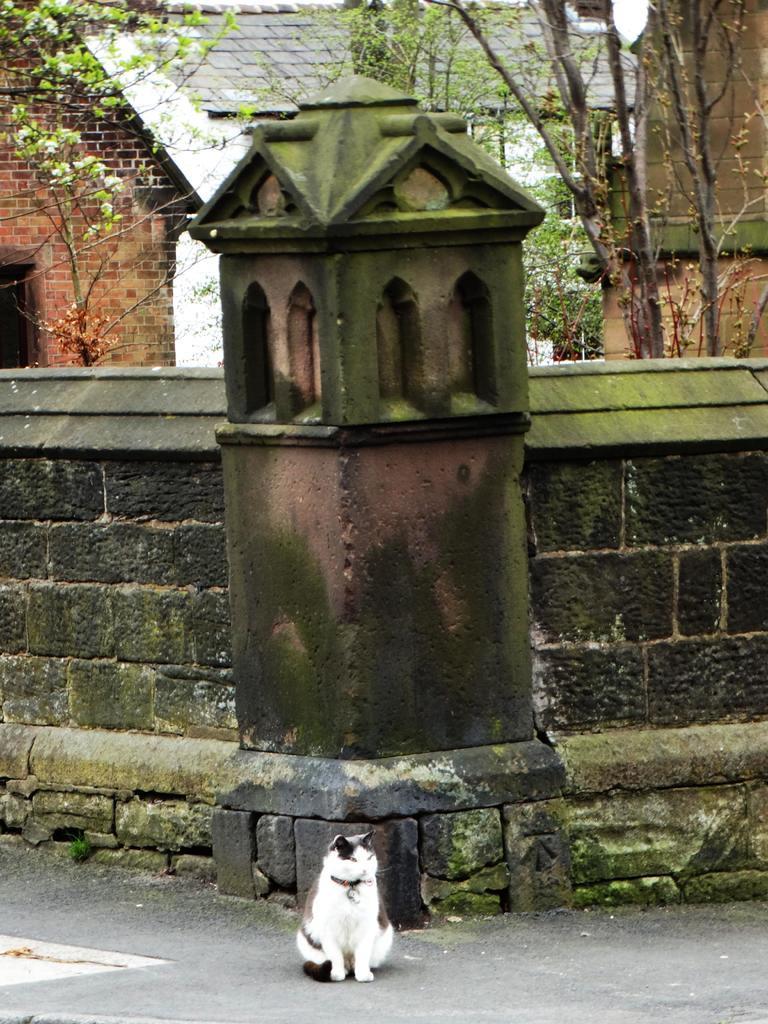Could you give a brief overview of what you see in this image? In this picture, there is a cat at the bottom. Behind it, there is a wall. On the top, there are trees, houses etc. 